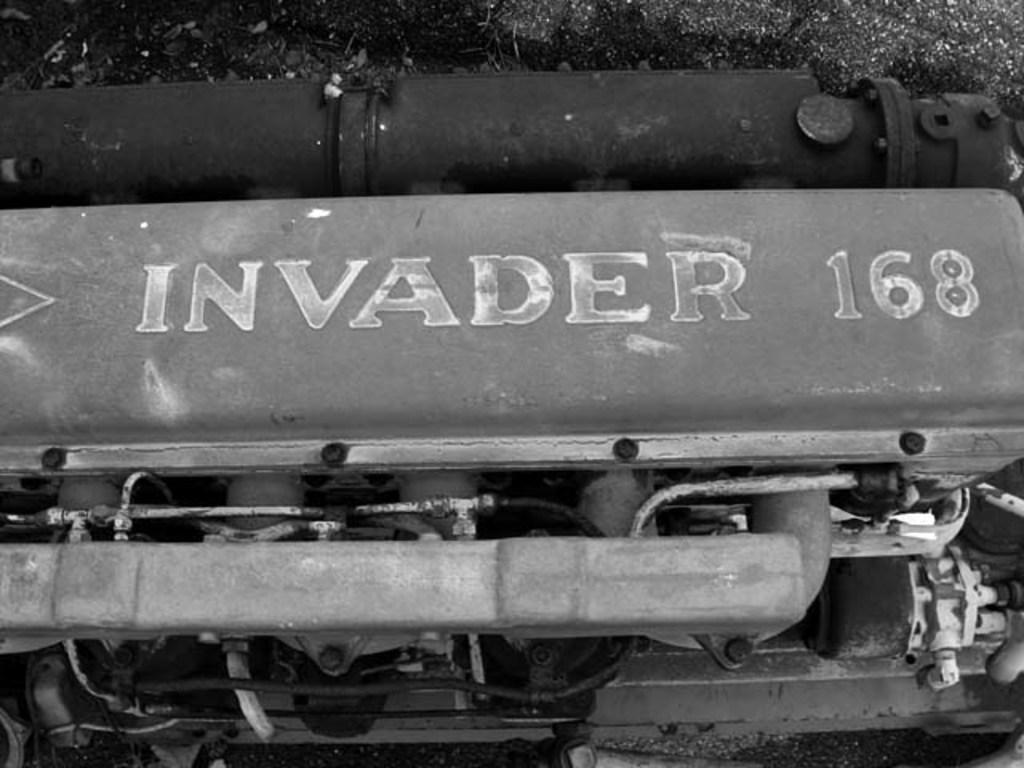Provide a one-sentence caption for the provided image. A large engine is marked as Invader 168. 